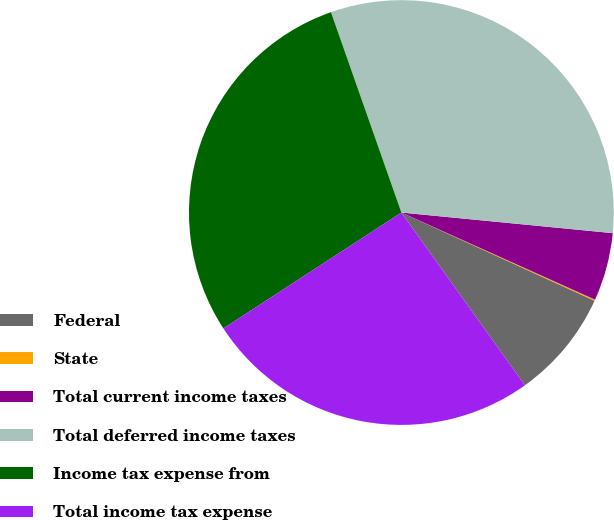Convert chart to OTSL. <chart><loc_0><loc_0><loc_500><loc_500><pie_chart><fcel>Federal<fcel>State<fcel>Total current income taxes<fcel>Total deferred income taxes<fcel>Income tax expense from<fcel>Total income tax expense<nl><fcel>8.3%<fcel>0.09%<fcel>5.18%<fcel>31.93%<fcel>28.81%<fcel>25.7%<nl></chart> 